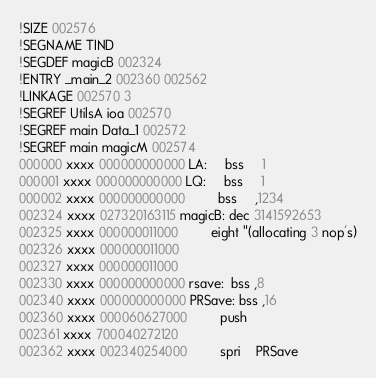<code> <loc_0><loc_0><loc_500><loc_500><_Octave_>!SIZE 002576
!SEGNAME TIND
!SEGDEF magicB 002324
!ENTRY _main_2 002360 002562
!LINKAGE 002570 3
!SEGREF UtilsA ioa 002570
!SEGREF main Data_1 002572
!SEGREF main magicM 002574
000000 xxxx 000000000000 LA:     bss     1
000001 xxxx 000000000000 LQ:     bss     1
000002 xxxx 000000000000         bss     ,1234
002324 xxxx 027320163115 magicB: dec 3141592653
002325 xxxx 000000011000         eight "(allocating 3 nop's)
002326 xxxx 000000011000 
002327 xxxx 000000011000 
002330 xxxx 000000000000 rsave:  bss ,8
002340 xxxx 000000000000 PRSave: bss ,16
002360 xxxx 000060627000         push    
002361 xxxx 700040272120 
002362 xxxx 002340254000         spri    PRSave</code> 